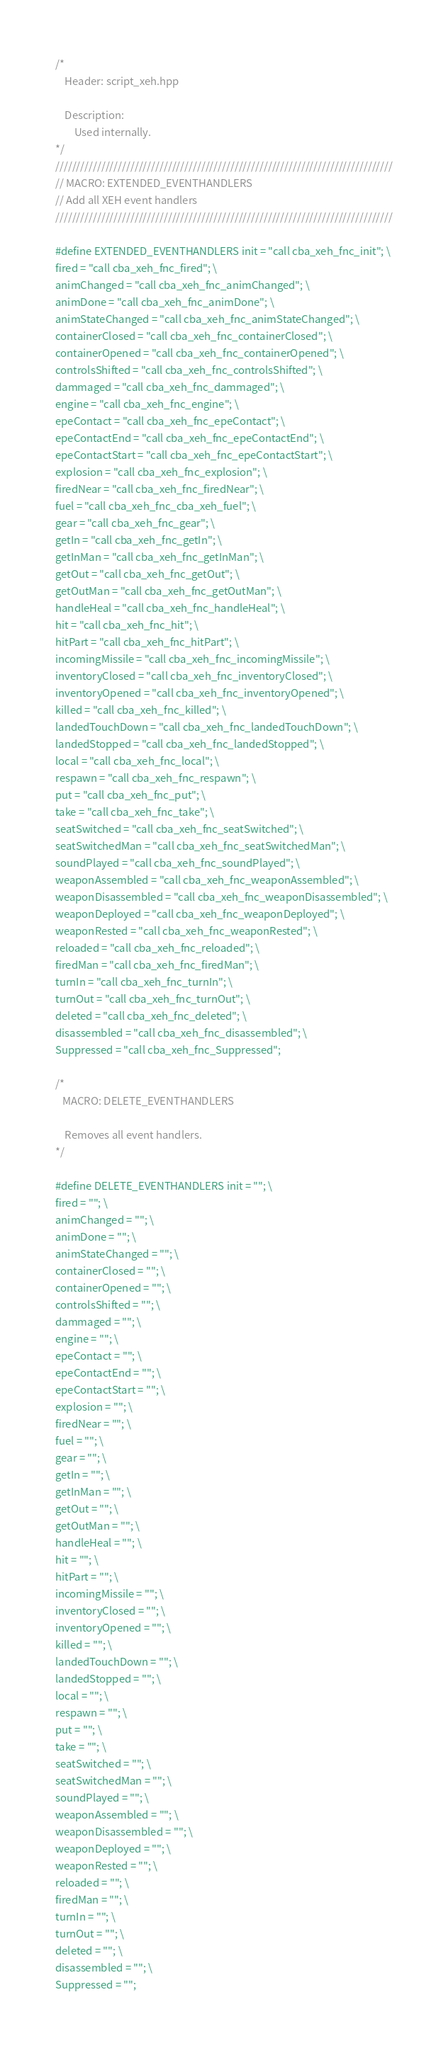<code> <loc_0><loc_0><loc_500><loc_500><_C++_>/*
    Header: script_xeh.hpp

    Description:
        Used internally.
*/
/////////////////////////////////////////////////////////////////////////////////
// MACRO: EXTENDED_EVENTHANDLERS
// Add all XEH event handlers
/////////////////////////////////////////////////////////////////////////////////

#define EXTENDED_EVENTHANDLERS init = "call cba_xeh_fnc_init"; \
fired = "call cba_xeh_fnc_fired"; \
animChanged = "call cba_xeh_fnc_animChanged"; \
animDone = "call cba_xeh_fnc_animDone"; \
animStateChanged = "call cba_xeh_fnc_animStateChanged"; \
containerClosed = "call cba_xeh_fnc_containerClosed"; \
containerOpened = "call cba_xeh_fnc_containerOpened"; \
controlsShifted = "call cba_xeh_fnc_controlsShifted"; \
dammaged = "call cba_xeh_fnc_dammaged"; \
engine = "call cba_xeh_fnc_engine"; \
epeContact = "call cba_xeh_fnc_epeContact"; \
epeContactEnd = "call cba_xeh_fnc_epeContactEnd"; \
epeContactStart = "call cba_xeh_fnc_epeContactStart"; \
explosion = "call cba_xeh_fnc_explosion"; \
firedNear = "call cba_xeh_fnc_firedNear"; \
fuel = "call cba_xeh_fnc_cba_xeh_fuel"; \
gear = "call cba_xeh_fnc_gear"; \
getIn = "call cba_xeh_fnc_getIn"; \
getInMan = "call cba_xeh_fnc_getInMan"; \
getOut = "call cba_xeh_fnc_getOut"; \
getOutMan = "call cba_xeh_fnc_getOutMan"; \
handleHeal = "call cba_xeh_fnc_handleHeal"; \
hit = "call cba_xeh_fnc_hit"; \
hitPart = "call cba_xeh_fnc_hitPart"; \
incomingMissile = "call cba_xeh_fnc_incomingMissile"; \
inventoryClosed = "call cba_xeh_fnc_inventoryClosed"; \
inventoryOpened = "call cba_xeh_fnc_inventoryOpened"; \
killed = "call cba_xeh_fnc_killed"; \
landedTouchDown = "call cba_xeh_fnc_landedTouchDown"; \
landedStopped = "call cba_xeh_fnc_landedStopped"; \
local = "call cba_xeh_fnc_local"; \
respawn = "call cba_xeh_fnc_respawn"; \
put = "call cba_xeh_fnc_put"; \
take = "call cba_xeh_fnc_take"; \
seatSwitched = "call cba_xeh_fnc_seatSwitched"; \
seatSwitchedMan = "call cba_xeh_fnc_seatSwitchedMan"; \
soundPlayed = "call cba_xeh_fnc_soundPlayed"; \
weaponAssembled = "call cba_xeh_fnc_weaponAssembled"; \
weaponDisassembled = "call cba_xeh_fnc_weaponDisassembled"; \
weaponDeployed = "call cba_xeh_fnc_weaponDeployed"; \
weaponRested = "call cba_xeh_fnc_weaponRested"; \
reloaded = "call cba_xeh_fnc_reloaded"; \
firedMan = "call cba_xeh_fnc_firedMan"; \
turnIn = "call cba_xeh_fnc_turnIn"; \
turnOut = "call cba_xeh_fnc_turnOut"; \
deleted = "call cba_xeh_fnc_deleted"; \
disassembled = "call cba_xeh_fnc_disassembled"; \
Suppressed = "call cba_xeh_fnc_Suppressed";

/*
   MACRO: DELETE_EVENTHANDLERS

    Removes all event handlers.
*/

#define DELETE_EVENTHANDLERS init = ""; \
fired = ""; \
animChanged = ""; \
animDone = ""; \
animStateChanged = ""; \
containerClosed = ""; \
containerOpened = ""; \
controlsShifted = ""; \
dammaged = ""; \
engine = ""; \
epeContact = ""; \
epeContactEnd = ""; \
epeContactStart = ""; \
explosion = ""; \
firedNear = ""; \
fuel = ""; \
gear = ""; \
getIn = ""; \
getInMan = ""; \
getOut = ""; \
getOutMan = ""; \
handleHeal = ""; \
hit = ""; \
hitPart = ""; \
incomingMissile = ""; \
inventoryClosed = ""; \
inventoryOpened = ""; \
killed = ""; \
landedTouchDown = ""; \
landedStopped = ""; \
local = ""; \
respawn = ""; \
put = ""; \
take = ""; \
seatSwitched = ""; \
seatSwitchedMan = ""; \
soundPlayed = ""; \
weaponAssembled = ""; \
weaponDisassembled = ""; \
weaponDeployed = ""; \
weaponRested = ""; \
reloaded = ""; \
firedMan = ""; \
turnIn = ""; \
turnOut = ""; \
deleted = ""; \
disassembled = ""; \
Suppressed = "";</code> 